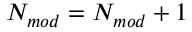<formula> <loc_0><loc_0><loc_500><loc_500>N _ { m o d } = N _ { m o d } + 1</formula> 